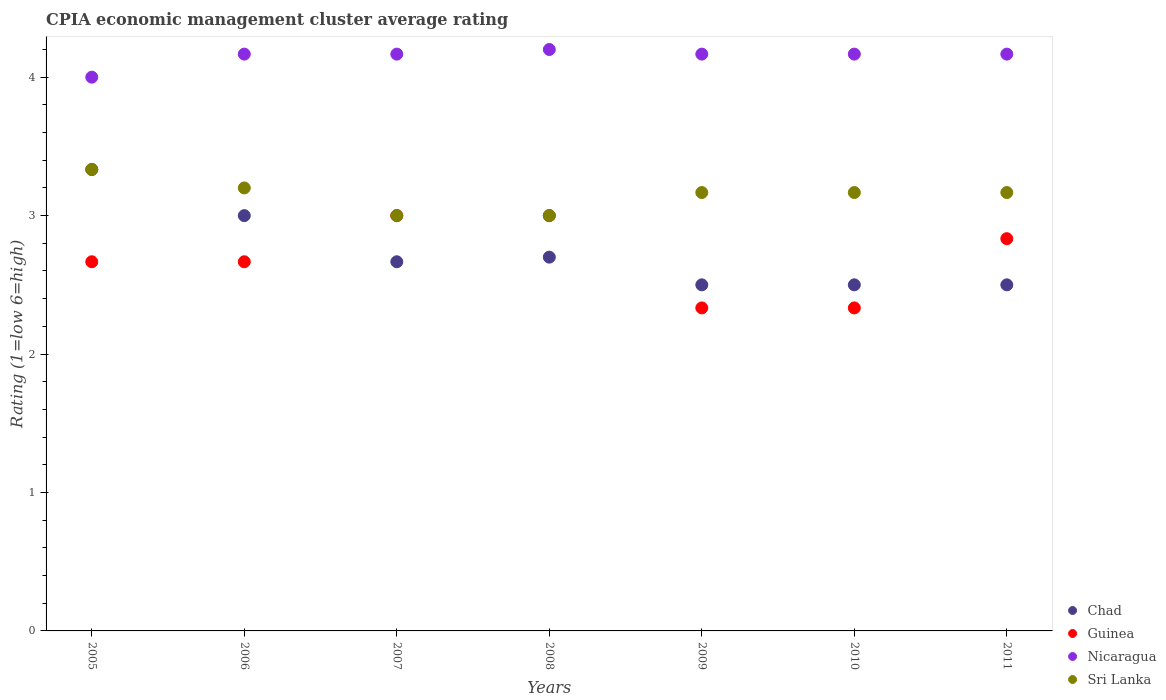How many different coloured dotlines are there?
Make the answer very short. 4. What is the CPIA rating in Chad in 2007?
Your answer should be compact. 2.67. What is the total CPIA rating in Nicaragua in the graph?
Offer a very short reply. 29.03. What is the difference between the CPIA rating in Sri Lanka in 2006 and that in 2008?
Your answer should be compact. 0.2. What is the difference between the CPIA rating in Nicaragua in 2005 and the CPIA rating in Sri Lanka in 2010?
Provide a short and direct response. 0.83. What is the average CPIA rating in Nicaragua per year?
Ensure brevity in your answer.  4.15. In the year 2011, what is the difference between the CPIA rating in Chad and CPIA rating in Sri Lanka?
Provide a succinct answer. -0.67. In how many years, is the CPIA rating in Chad greater than 2?
Offer a terse response. 7. What is the ratio of the CPIA rating in Sri Lanka in 2005 to that in 2011?
Make the answer very short. 1.05. Is the CPIA rating in Nicaragua in 2005 less than that in 2011?
Give a very brief answer. Yes. Is the difference between the CPIA rating in Chad in 2005 and 2008 greater than the difference between the CPIA rating in Sri Lanka in 2005 and 2008?
Offer a terse response. Yes. What is the difference between the highest and the second highest CPIA rating in Guinea?
Make the answer very short. 0. What is the difference between the highest and the lowest CPIA rating in Guinea?
Provide a succinct answer. 0.67. Is it the case that in every year, the sum of the CPIA rating in Chad and CPIA rating in Guinea  is greater than the CPIA rating in Sri Lanka?
Provide a succinct answer. Yes. How many dotlines are there?
Make the answer very short. 4. Are the values on the major ticks of Y-axis written in scientific E-notation?
Your answer should be compact. No. Where does the legend appear in the graph?
Give a very brief answer. Bottom right. How many legend labels are there?
Give a very brief answer. 4. What is the title of the graph?
Provide a short and direct response. CPIA economic management cluster average rating. What is the label or title of the Y-axis?
Your response must be concise. Rating (1=low 6=high). What is the Rating (1=low 6=high) in Chad in 2005?
Your response must be concise. 3.33. What is the Rating (1=low 6=high) in Guinea in 2005?
Ensure brevity in your answer.  2.67. What is the Rating (1=low 6=high) in Sri Lanka in 2005?
Give a very brief answer. 3.33. What is the Rating (1=low 6=high) in Chad in 2006?
Keep it short and to the point. 3. What is the Rating (1=low 6=high) of Guinea in 2006?
Offer a very short reply. 2.67. What is the Rating (1=low 6=high) of Nicaragua in 2006?
Your answer should be very brief. 4.17. What is the Rating (1=low 6=high) in Chad in 2007?
Offer a terse response. 2.67. What is the Rating (1=low 6=high) of Nicaragua in 2007?
Your response must be concise. 4.17. What is the Rating (1=low 6=high) in Guinea in 2008?
Keep it short and to the point. 3. What is the Rating (1=low 6=high) of Nicaragua in 2008?
Your answer should be very brief. 4.2. What is the Rating (1=low 6=high) in Chad in 2009?
Provide a succinct answer. 2.5. What is the Rating (1=low 6=high) in Guinea in 2009?
Your response must be concise. 2.33. What is the Rating (1=low 6=high) of Nicaragua in 2009?
Make the answer very short. 4.17. What is the Rating (1=low 6=high) in Sri Lanka in 2009?
Your answer should be very brief. 3.17. What is the Rating (1=low 6=high) in Chad in 2010?
Provide a short and direct response. 2.5. What is the Rating (1=low 6=high) in Guinea in 2010?
Offer a very short reply. 2.33. What is the Rating (1=low 6=high) of Nicaragua in 2010?
Keep it short and to the point. 4.17. What is the Rating (1=low 6=high) of Sri Lanka in 2010?
Provide a succinct answer. 3.17. What is the Rating (1=low 6=high) of Guinea in 2011?
Your answer should be very brief. 2.83. What is the Rating (1=low 6=high) of Nicaragua in 2011?
Give a very brief answer. 4.17. What is the Rating (1=low 6=high) in Sri Lanka in 2011?
Give a very brief answer. 3.17. Across all years, what is the maximum Rating (1=low 6=high) in Chad?
Give a very brief answer. 3.33. Across all years, what is the maximum Rating (1=low 6=high) in Sri Lanka?
Make the answer very short. 3.33. Across all years, what is the minimum Rating (1=low 6=high) in Chad?
Ensure brevity in your answer.  2.5. Across all years, what is the minimum Rating (1=low 6=high) of Guinea?
Provide a succinct answer. 2.33. Across all years, what is the minimum Rating (1=low 6=high) in Nicaragua?
Keep it short and to the point. 4. Across all years, what is the minimum Rating (1=low 6=high) of Sri Lanka?
Your answer should be very brief. 3. What is the total Rating (1=low 6=high) of Guinea in the graph?
Make the answer very short. 18.83. What is the total Rating (1=low 6=high) in Nicaragua in the graph?
Give a very brief answer. 29.03. What is the total Rating (1=low 6=high) in Sri Lanka in the graph?
Provide a short and direct response. 22.03. What is the difference between the Rating (1=low 6=high) in Chad in 2005 and that in 2006?
Offer a very short reply. 0.33. What is the difference between the Rating (1=low 6=high) of Nicaragua in 2005 and that in 2006?
Offer a terse response. -0.17. What is the difference between the Rating (1=low 6=high) of Sri Lanka in 2005 and that in 2006?
Your answer should be very brief. 0.13. What is the difference between the Rating (1=low 6=high) in Chad in 2005 and that in 2007?
Your response must be concise. 0.67. What is the difference between the Rating (1=low 6=high) in Nicaragua in 2005 and that in 2007?
Give a very brief answer. -0.17. What is the difference between the Rating (1=low 6=high) of Sri Lanka in 2005 and that in 2007?
Offer a very short reply. 0.33. What is the difference between the Rating (1=low 6=high) in Chad in 2005 and that in 2008?
Offer a terse response. 0.63. What is the difference between the Rating (1=low 6=high) in Nicaragua in 2005 and that in 2011?
Keep it short and to the point. -0.17. What is the difference between the Rating (1=low 6=high) of Sri Lanka in 2005 and that in 2011?
Make the answer very short. 0.17. What is the difference between the Rating (1=low 6=high) of Chad in 2006 and that in 2007?
Ensure brevity in your answer.  0.33. What is the difference between the Rating (1=low 6=high) of Guinea in 2006 and that in 2007?
Provide a short and direct response. -0.33. What is the difference between the Rating (1=low 6=high) of Nicaragua in 2006 and that in 2007?
Keep it short and to the point. 0. What is the difference between the Rating (1=low 6=high) in Sri Lanka in 2006 and that in 2007?
Offer a terse response. 0.2. What is the difference between the Rating (1=low 6=high) of Chad in 2006 and that in 2008?
Ensure brevity in your answer.  0.3. What is the difference between the Rating (1=low 6=high) of Nicaragua in 2006 and that in 2008?
Your answer should be compact. -0.03. What is the difference between the Rating (1=low 6=high) in Sri Lanka in 2006 and that in 2009?
Offer a very short reply. 0.03. What is the difference between the Rating (1=low 6=high) in Guinea in 2006 and that in 2010?
Provide a succinct answer. 0.33. What is the difference between the Rating (1=low 6=high) in Nicaragua in 2006 and that in 2010?
Your response must be concise. 0. What is the difference between the Rating (1=low 6=high) of Nicaragua in 2006 and that in 2011?
Your answer should be very brief. 0. What is the difference between the Rating (1=low 6=high) of Sri Lanka in 2006 and that in 2011?
Make the answer very short. 0.03. What is the difference between the Rating (1=low 6=high) of Chad in 2007 and that in 2008?
Your response must be concise. -0.03. What is the difference between the Rating (1=low 6=high) in Guinea in 2007 and that in 2008?
Ensure brevity in your answer.  0. What is the difference between the Rating (1=low 6=high) of Nicaragua in 2007 and that in 2008?
Keep it short and to the point. -0.03. What is the difference between the Rating (1=low 6=high) of Sri Lanka in 2007 and that in 2008?
Give a very brief answer. 0. What is the difference between the Rating (1=low 6=high) in Chad in 2007 and that in 2010?
Provide a short and direct response. 0.17. What is the difference between the Rating (1=low 6=high) in Guinea in 2007 and that in 2010?
Your response must be concise. 0.67. What is the difference between the Rating (1=low 6=high) in Sri Lanka in 2007 and that in 2011?
Provide a succinct answer. -0.17. What is the difference between the Rating (1=low 6=high) in Chad in 2008 and that in 2009?
Your response must be concise. 0.2. What is the difference between the Rating (1=low 6=high) in Guinea in 2008 and that in 2009?
Provide a short and direct response. 0.67. What is the difference between the Rating (1=low 6=high) in Nicaragua in 2008 and that in 2009?
Offer a terse response. 0.03. What is the difference between the Rating (1=low 6=high) in Sri Lanka in 2008 and that in 2009?
Give a very brief answer. -0.17. What is the difference between the Rating (1=low 6=high) in Chad in 2008 and that in 2010?
Offer a very short reply. 0.2. What is the difference between the Rating (1=low 6=high) in Guinea in 2008 and that in 2010?
Keep it short and to the point. 0.67. What is the difference between the Rating (1=low 6=high) in Nicaragua in 2008 and that in 2010?
Your answer should be very brief. 0.03. What is the difference between the Rating (1=low 6=high) of Sri Lanka in 2008 and that in 2010?
Keep it short and to the point. -0.17. What is the difference between the Rating (1=low 6=high) of Chad in 2008 and that in 2011?
Ensure brevity in your answer.  0.2. What is the difference between the Rating (1=low 6=high) in Guinea in 2008 and that in 2011?
Give a very brief answer. 0.17. What is the difference between the Rating (1=low 6=high) in Nicaragua in 2008 and that in 2011?
Your answer should be very brief. 0.03. What is the difference between the Rating (1=low 6=high) of Sri Lanka in 2008 and that in 2011?
Offer a very short reply. -0.17. What is the difference between the Rating (1=low 6=high) of Chad in 2009 and that in 2010?
Provide a succinct answer. 0. What is the difference between the Rating (1=low 6=high) in Guinea in 2009 and that in 2010?
Offer a very short reply. 0. What is the difference between the Rating (1=low 6=high) of Nicaragua in 2009 and that in 2010?
Provide a succinct answer. 0. What is the difference between the Rating (1=low 6=high) of Sri Lanka in 2009 and that in 2010?
Ensure brevity in your answer.  0. What is the difference between the Rating (1=low 6=high) of Chad in 2009 and that in 2011?
Your answer should be very brief. 0. What is the difference between the Rating (1=low 6=high) in Guinea in 2010 and that in 2011?
Keep it short and to the point. -0.5. What is the difference between the Rating (1=low 6=high) of Nicaragua in 2010 and that in 2011?
Keep it short and to the point. 0. What is the difference between the Rating (1=low 6=high) of Sri Lanka in 2010 and that in 2011?
Your response must be concise. 0. What is the difference between the Rating (1=low 6=high) in Chad in 2005 and the Rating (1=low 6=high) in Guinea in 2006?
Offer a terse response. 0.67. What is the difference between the Rating (1=low 6=high) in Chad in 2005 and the Rating (1=low 6=high) in Nicaragua in 2006?
Your response must be concise. -0.83. What is the difference between the Rating (1=low 6=high) of Chad in 2005 and the Rating (1=low 6=high) of Sri Lanka in 2006?
Offer a very short reply. 0.13. What is the difference between the Rating (1=low 6=high) in Guinea in 2005 and the Rating (1=low 6=high) in Nicaragua in 2006?
Make the answer very short. -1.5. What is the difference between the Rating (1=low 6=high) in Guinea in 2005 and the Rating (1=low 6=high) in Sri Lanka in 2006?
Keep it short and to the point. -0.53. What is the difference between the Rating (1=low 6=high) of Nicaragua in 2005 and the Rating (1=low 6=high) of Sri Lanka in 2006?
Your answer should be very brief. 0.8. What is the difference between the Rating (1=low 6=high) of Chad in 2005 and the Rating (1=low 6=high) of Guinea in 2007?
Provide a short and direct response. 0.33. What is the difference between the Rating (1=low 6=high) in Chad in 2005 and the Rating (1=low 6=high) in Sri Lanka in 2007?
Make the answer very short. 0.33. What is the difference between the Rating (1=low 6=high) of Nicaragua in 2005 and the Rating (1=low 6=high) of Sri Lanka in 2007?
Provide a short and direct response. 1. What is the difference between the Rating (1=low 6=high) in Chad in 2005 and the Rating (1=low 6=high) in Guinea in 2008?
Provide a short and direct response. 0.33. What is the difference between the Rating (1=low 6=high) of Chad in 2005 and the Rating (1=low 6=high) of Nicaragua in 2008?
Your answer should be very brief. -0.87. What is the difference between the Rating (1=low 6=high) in Chad in 2005 and the Rating (1=low 6=high) in Sri Lanka in 2008?
Keep it short and to the point. 0.33. What is the difference between the Rating (1=low 6=high) of Guinea in 2005 and the Rating (1=low 6=high) of Nicaragua in 2008?
Make the answer very short. -1.53. What is the difference between the Rating (1=low 6=high) in Guinea in 2005 and the Rating (1=low 6=high) in Sri Lanka in 2008?
Your answer should be compact. -0.33. What is the difference between the Rating (1=low 6=high) in Nicaragua in 2005 and the Rating (1=low 6=high) in Sri Lanka in 2008?
Give a very brief answer. 1. What is the difference between the Rating (1=low 6=high) in Chad in 2005 and the Rating (1=low 6=high) in Sri Lanka in 2009?
Offer a terse response. 0.17. What is the difference between the Rating (1=low 6=high) of Guinea in 2005 and the Rating (1=low 6=high) of Sri Lanka in 2009?
Provide a short and direct response. -0.5. What is the difference between the Rating (1=low 6=high) of Nicaragua in 2005 and the Rating (1=low 6=high) of Sri Lanka in 2009?
Your answer should be compact. 0.83. What is the difference between the Rating (1=low 6=high) of Chad in 2005 and the Rating (1=low 6=high) of Guinea in 2010?
Keep it short and to the point. 1. What is the difference between the Rating (1=low 6=high) in Guinea in 2005 and the Rating (1=low 6=high) in Nicaragua in 2010?
Ensure brevity in your answer.  -1.5. What is the difference between the Rating (1=low 6=high) in Nicaragua in 2005 and the Rating (1=low 6=high) in Sri Lanka in 2010?
Keep it short and to the point. 0.83. What is the difference between the Rating (1=low 6=high) in Chad in 2005 and the Rating (1=low 6=high) in Guinea in 2011?
Provide a short and direct response. 0.5. What is the difference between the Rating (1=low 6=high) in Chad in 2005 and the Rating (1=low 6=high) in Sri Lanka in 2011?
Offer a terse response. 0.17. What is the difference between the Rating (1=low 6=high) of Guinea in 2005 and the Rating (1=low 6=high) of Nicaragua in 2011?
Provide a succinct answer. -1.5. What is the difference between the Rating (1=low 6=high) in Chad in 2006 and the Rating (1=low 6=high) in Guinea in 2007?
Your response must be concise. 0. What is the difference between the Rating (1=low 6=high) in Chad in 2006 and the Rating (1=low 6=high) in Nicaragua in 2007?
Ensure brevity in your answer.  -1.17. What is the difference between the Rating (1=low 6=high) of Guinea in 2006 and the Rating (1=low 6=high) of Nicaragua in 2007?
Provide a short and direct response. -1.5. What is the difference between the Rating (1=low 6=high) in Chad in 2006 and the Rating (1=low 6=high) in Nicaragua in 2008?
Your response must be concise. -1.2. What is the difference between the Rating (1=low 6=high) of Guinea in 2006 and the Rating (1=low 6=high) of Nicaragua in 2008?
Offer a terse response. -1.53. What is the difference between the Rating (1=low 6=high) of Nicaragua in 2006 and the Rating (1=low 6=high) of Sri Lanka in 2008?
Offer a terse response. 1.17. What is the difference between the Rating (1=low 6=high) in Chad in 2006 and the Rating (1=low 6=high) in Nicaragua in 2009?
Your answer should be very brief. -1.17. What is the difference between the Rating (1=low 6=high) of Chad in 2006 and the Rating (1=low 6=high) of Sri Lanka in 2009?
Give a very brief answer. -0.17. What is the difference between the Rating (1=low 6=high) of Nicaragua in 2006 and the Rating (1=low 6=high) of Sri Lanka in 2009?
Provide a succinct answer. 1. What is the difference between the Rating (1=low 6=high) in Chad in 2006 and the Rating (1=low 6=high) in Nicaragua in 2010?
Give a very brief answer. -1.17. What is the difference between the Rating (1=low 6=high) in Guinea in 2006 and the Rating (1=low 6=high) in Nicaragua in 2010?
Keep it short and to the point. -1.5. What is the difference between the Rating (1=low 6=high) in Guinea in 2006 and the Rating (1=low 6=high) in Sri Lanka in 2010?
Your answer should be very brief. -0.5. What is the difference between the Rating (1=low 6=high) of Nicaragua in 2006 and the Rating (1=low 6=high) of Sri Lanka in 2010?
Provide a succinct answer. 1. What is the difference between the Rating (1=low 6=high) in Chad in 2006 and the Rating (1=low 6=high) in Guinea in 2011?
Give a very brief answer. 0.17. What is the difference between the Rating (1=low 6=high) in Chad in 2006 and the Rating (1=low 6=high) in Nicaragua in 2011?
Keep it short and to the point. -1.17. What is the difference between the Rating (1=low 6=high) in Guinea in 2006 and the Rating (1=low 6=high) in Nicaragua in 2011?
Offer a very short reply. -1.5. What is the difference between the Rating (1=low 6=high) in Guinea in 2006 and the Rating (1=low 6=high) in Sri Lanka in 2011?
Offer a very short reply. -0.5. What is the difference between the Rating (1=low 6=high) of Nicaragua in 2006 and the Rating (1=low 6=high) of Sri Lanka in 2011?
Give a very brief answer. 1. What is the difference between the Rating (1=low 6=high) in Chad in 2007 and the Rating (1=low 6=high) in Guinea in 2008?
Your answer should be compact. -0.33. What is the difference between the Rating (1=low 6=high) in Chad in 2007 and the Rating (1=low 6=high) in Nicaragua in 2008?
Give a very brief answer. -1.53. What is the difference between the Rating (1=low 6=high) in Chad in 2007 and the Rating (1=low 6=high) in Nicaragua in 2009?
Your answer should be compact. -1.5. What is the difference between the Rating (1=low 6=high) of Guinea in 2007 and the Rating (1=low 6=high) of Nicaragua in 2009?
Keep it short and to the point. -1.17. What is the difference between the Rating (1=low 6=high) in Nicaragua in 2007 and the Rating (1=low 6=high) in Sri Lanka in 2009?
Provide a short and direct response. 1. What is the difference between the Rating (1=low 6=high) of Chad in 2007 and the Rating (1=low 6=high) of Nicaragua in 2010?
Your response must be concise. -1.5. What is the difference between the Rating (1=low 6=high) of Guinea in 2007 and the Rating (1=low 6=high) of Nicaragua in 2010?
Your answer should be very brief. -1.17. What is the difference between the Rating (1=low 6=high) of Nicaragua in 2007 and the Rating (1=low 6=high) of Sri Lanka in 2010?
Your response must be concise. 1. What is the difference between the Rating (1=low 6=high) in Chad in 2007 and the Rating (1=low 6=high) in Guinea in 2011?
Provide a short and direct response. -0.17. What is the difference between the Rating (1=low 6=high) in Chad in 2007 and the Rating (1=low 6=high) in Nicaragua in 2011?
Keep it short and to the point. -1.5. What is the difference between the Rating (1=low 6=high) of Chad in 2007 and the Rating (1=low 6=high) of Sri Lanka in 2011?
Provide a succinct answer. -0.5. What is the difference between the Rating (1=low 6=high) in Guinea in 2007 and the Rating (1=low 6=high) in Nicaragua in 2011?
Your response must be concise. -1.17. What is the difference between the Rating (1=low 6=high) in Guinea in 2007 and the Rating (1=low 6=high) in Sri Lanka in 2011?
Offer a very short reply. -0.17. What is the difference between the Rating (1=low 6=high) of Chad in 2008 and the Rating (1=low 6=high) of Guinea in 2009?
Make the answer very short. 0.37. What is the difference between the Rating (1=low 6=high) in Chad in 2008 and the Rating (1=low 6=high) in Nicaragua in 2009?
Give a very brief answer. -1.47. What is the difference between the Rating (1=low 6=high) in Chad in 2008 and the Rating (1=low 6=high) in Sri Lanka in 2009?
Give a very brief answer. -0.47. What is the difference between the Rating (1=low 6=high) of Guinea in 2008 and the Rating (1=low 6=high) of Nicaragua in 2009?
Your answer should be very brief. -1.17. What is the difference between the Rating (1=low 6=high) of Guinea in 2008 and the Rating (1=low 6=high) of Sri Lanka in 2009?
Make the answer very short. -0.17. What is the difference between the Rating (1=low 6=high) of Nicaragua in 2008 and the Rating (1=low 6=high) of Sri Lanka in 2009?
Your answer should be very brief. 1.03. What is the difference between the Rating (1=low 6=high) in Chad in 2008 and the Rating (1=low 6=high) in Guinea in 2010?
Give a very brief answer. 0.37. What is the difference between the Rating (1=low 6=high) in Chad in 2008 and the Rating (1=low 6=high) in Nicaragua in 2010?
Offer a very short reply. -1.47. What is the difference between the Rating (1=low 6=high) of Chad in 2008 and the Rating (1=low 6=high) of Sri Lanka in 2010?
Offer a terse response. -0.47. What is the difference between the Rating (1=low 6=high) in Guinea in 2008 and the Rating (1=low 6=high) in Nicaragua in 2010?
Keep it short and to the point. -1.17. What is the difference between the Rating (1=low 6=high) in Chad in 2008 and the Rating (1=low 6=high) in Guinea in 2011?
Your answer should be very brief. -0.13. What is the difference between the Rating (1=low 6=high) of Chad in 2008 and the Rating (1=low 6=high) of Nicaragua in 2011?
Make the answer very short. -1.47. What is the difference between the Rating (1=low 6=high) in Chad in 2008 and the Rating (1=low 6=high) in Sri Lanka in 2011?
Ensure brevity in your answer.  -0.47. What is the difference between the Rating (1=low 6=high) in Guinea in 2008 and the Rating (1=low 6=high) in Nicaragua in 2011?
Give a very brief answer. -1.17. What is the difference between the Rating (1=low 6=high) in Chad in 2009 and the Rating (1=low 6=high) in Guinea in 2010?
Make the answer very short. 0.17. What is the difference between the Rating (1=low 6=high) in Chad in 2009 and the Rating (1=low 6=high) in Nicaragua in 2010?
Your answer should be very brief. -1.67. What is the difference between the Rating (1=low 6=high) in Guinea in 2009 and the Rating (1=low 6=high) in Nicaragua in 2010?
Provide a succinct answer. -1.83. What is the difference between the Rating (1=low 6=high) in Guinea in 2009 and the Rating (1=low 6=high) in Sri Lanka in 2010?
Provide a succinct answer. -0.83. What is the difference between the Rating (1=low 6=high) of Chad in 2009 and the Rating (1=low 6=high) of Guinea in 2011?
Your response must be concise. -0.33. What is the difference between the Rating (1=low 6=high) of Chad in 2009 and the Rating (1=low 6=high) of Nicaragua in 2011?
Offer a very short reply. -1.67. What is the difference between the Rating (1=low 6=high) in Guinea in 2009 and the Rating (1=low 6=high) in Nicaragua in 2011?
Offer a very short reply. -1.83. What is the difference between the Rating (1=low 6=high) in Guinea in 2009 and the Rating (1=low 6=high) in Sri Lanka in 2011?
Your answer should be compact. -0.83. What is the difference between the Rating (1=low 6=high) in Nicaragua in 2009 and the Rating (1=low 6=high) in Sri Lanka in 2011?
Your answer should be compact. 1. What is the difference between the Rating (1=low 6=high) in Chad in 2010 and the Rating (1=low 6=high) in Guinea in 2011?
Provide a succinct answer. -0.33. What is the difference between the Rating (1=low 6=high) of Chad in 2010 and the Rating (1=low 6=high) of Nicaragua in 2011?
Make the answer very short. -1.67. What is the difference between the Rating (1=low 6=high) of Chad in 2010 and the Rating (1=low 6=high) of Sri Lanka in 2011?
Your answer should be very brief. -0.67. What is the difference between the Rating (1=low 6=high) in Guinea in 2010 and the Rating (1=low 6=high) in Nicaragua in 2011?
Your answer should be very brief. -1.83. What is the difference between the Rating (1=low 6=high) of Guinea in 2010 and the Rating (1=low 6=high) of Sri Lanka in 2011?
Make the answer very short. -0.83. What is the average Rating (1=low 6=high) of Chad per year?
Offer a very short reply. 2.74. What is the average Rating (1=low 6=high) in Guinea per year?
Your answer should be compact. 2.69. What is the average Rating (1=low 6=high) in Nicaragua per year?
Provide a short and direct response. 4.15. What is the average Rating (1=low 6=high) in Sri Lanka per year?
Keep it short and to the point. 3.15. In the year 2005, what is the difference between the Rating (1=low 6=high) of Chad and Rating (1=low 6=high) of Guinea?
Provide a succinct answer. 0.67. In the year 2005, what is the difference between the Rating (1=low 6=high) in Guinea and Rating (1=low 6=high) in Nicaragua?
Your answer should be compact. -1.33. In the year 2005, what is the difference between the Rating (1=low 6=high) in Guinea and Rating (1=low 6=high) in Sri Lanka?
Offer a terse response. -0.67. In the year 2006, what is the difference between the Rating (1=low 6=high) of Chad and Rating (1=low 6=high) of Nicaragua?
Your response must be concise. -1.17. In the year 2006, what is the difference between the Rating (1=low 6=high) in Guinea and Rating (1=low 6=high) in Nicaragua?
Your response must be concise. -1.5. In the year 2006, what is the difference between the Rating (1=low 6=high) in Guinea and Rating (1=low 6=high) in Sri Lanka?
Offer a very short reply. -0.53. In the year 2006, what is the difference between the Rating (1=low 6=high) in Nicaragua and Rating (1=low 6=high) in Sri Lanka?
Give a very brief answer. 0.97. In the year 2007, what is the difference between the Rating (1=low 6=high) of Chad and Rating (1=low 6=high) of Nicaragua?
Offer a terse response. -1.5. In the year 2007, what is the difference between the Rating (1=low 6=high) in Chad and Rating (1=low 6=high) in Sri Lanka?
Your answer should be compact. -0.33. In the year 2007, what is the difference between the Rating (1=low 6=high) in Guinea and Rating (1=low 6=high) in Nicaragua?
Ensure brevity in your answer.  -1.17. In the year 2007, what is the difference between the Rating (1=low 6=high) of Guinea and Rating (1=low 6=high) of Sri Lanka?
Make the answer very short. 0. In the year 2008, what is the difference between the Rating (1=low 6=high) of Chad and Rating (1=low 6=high) of Nicaragua?
Ensure brevity in your answer.  -1.5. In the year 2008, what is the difference between the Rating (1=low 6=high) of Guinea and Rating (1=low 6=high) of Sri Lanka?
Your answer should be very brief. 0. In the year 2008, what is the difference between the Rating (1=low 6=high) of Nicaragua and Rating (1=low 6=high) of Sri Lanka?
Provide a succinct answer. 1.2. In the year 2009, what is the difference between the Rating (1=low 6=high) in Chad and Rating (1=low 6=high) in Nicaragua?
Provide a succinct answer. -1.67. In the year 2009, what is the difference between the Rating (1=low 6=high) of Chad and Rating (1=low 6=high) of Sri Lanka?
Your response must be concise. -0.67. In the year 2009, what is the difference between the Rating (1=low 6=high) of Guinea and Rating (1=low 6=high) of Nicaragua?
Offer a terse response. -1.83. In the year 2010, what is the difference between the Rating (1=low 6=high) in Chad and Rating (1=low 6=high) in Nicaragua?
Your response must be concise. -1.67. In the year 2010, what is the difference between the Rating (1=low 6=high) in Chad and Rating (1=low 6=high) in Sri Lanka?
Your answer should be very brief. -0.67. In the year 2010, what is the difference between the Rating (1=low 6=high) of Guinea and Rating (1=low 6=high) of Nicaragua?
Your response must be concise. -1.83. In the year 2010, what is the difference between the Rating (1=low 6=high) of Guinea and Rating (1=low 6=high) of Sri Lanka?
Offer a terse response. -0.83. In the year 2011, what is the difference between the Rating (1=low 6=high) in Chad and Rating (1=low 6=high) in Nicaragua?
Your answer should be compact. -1.67. In the year 2011, what is the difference between the Rating (1=low 6=high) in Guinea and Rating (1=low 6=high) in Nicaragua?
Offer a terse response. -1.33. In the year 2011, what is the difference between the Rating (1=low 6=high) of Guinea and Rating (1=low 6=high) of Sri Lanka?
Offer a very short reply. -0.33. In the year 2011, what is the difference between the Rating (1=low 6=high) of Nicaragua and Rating (1=low 6=high) of Sri Lanka?
Give a very brief answer. 1. What is the ratio of the Rating (1=low 6=high) in Chad in 2005 to that in 2006?
Ensure brevity in your answer.  1.11. What is the ratio of the Rating (1=low 6=high) of Guinea in 2005 to that in 2006?
Ensure brevity in your answer.  1. What is the ratio of the Rating (1=low 6=high) in Nicaragua in 2005 to that in 2006?
Ensure brevity in your answer.  0.96. What is the ratio of the Rating (1=low 6=high) in Sri Lanka in 2005 to that in 2006?
Provide a succinct answer. 1.04. What is the ratio of the Rating (1=low 6=high) of Guinea in 2005 to that in 2007?
Keep it short and to the point. 0.89. What is the ratio of the Rating (1=low 6=high) in Chad in 2005 to that in 2008?
Keep it short and to the point. 1.23. What is the ratio of the Rating (1=low 6=high) of Nicaragua in 2005 to that in 2009?
Give a very brief answer. 0.96. What is the ratio of the Rating (1=low 6=high) of Sri Lanka in 2005 to that in 2009?
Keep it short and to the point. 1.05. What is the ratio of the Rating (1=low 6=high) in Guinea in 2005 to that in 2010?
Make the answer very short. 1.14. What is the ratio of the Rating (1=low 6=high) of Sri Lanka in 2005 to that in 2010?
Offer a terse response. 1.05. What is the ratio of the Rating (1=low 6=high) in Guinea in 2005 to that in 2011?
Keep it short and to the point. 0.94. What is the ratio of the Rating (1=low 6=high) in Nicaragua in 2005 to that in 2011?
Make the answer very short. 0.96. What is the ratio of the Rating (1=low 6=high) of Sri Lanka in 2005 to that in 2011?
Provide a succinct answer. 1.05. What is the ratio of the Rating (1=low 6=high) in Guinea in 2006 to that in 2007?
Offer a terse response. 0.89. What is the ratio of the Rating (1=low 6=high) in Sri Lanka in 2006 to that in 2007?
Offer a terse response. 1.07. What is the ratio of the Rating (1=low 6=high) of Chad in 2006 to that in 2008?
Your answer should be compact. 1.11. What is the ratio of the Rating (1=low 6=high) of Guinea in 2006 to that in 2008?
Your response must be concise. 0.89. What is the ratio of the Rating (1=low 6=high) of Nicaragua in 2006 to that in 2008?
Give a very brief answer. 0.99. What is the ratio of the Rating (1=low 6=high) of Sri Lanka in 2006 to that in 2008?
Your response must be concise. 1.07. What is the ratio of the Rating (1=low 6=high) of Chad in 2006 to that in 2009?
Make the answer very short. 1.2. What is the ratio of the Rating (1=low 6=high) in Guinea in 2006 to that in 2009?
Your answer should be compact. 1.14. What is the ratio of the Rating (1=low 6=high) in Sri Lanka in 2006 to that in 2009?
Provide a succinct answer. 1.01. What is the ratio of the Rating (1=low 6=high) of Chad in 2006 to that in 2010?
Ensure brevity in your answer.  1.2. What is the ratio of the Rating (1=low 6=high) in Guinea in 2006 to that in 2010?
Keep it short and to the point. 1.14. What is the ratio of the Rating (1=low 6=high) of Sri Lanka in 2006 to that in 2010?
Your answer should be very brief. 1.01. What is the ratio of the Rating (1=low 6=high) in Chad in 2006 to that in 2011?
Make the answer very short. 1.2. What is the ratio of the Rating (1=low 6=high) in Guinea in 2006 to that in 2011?
Provide a succinct answer. 0.94. What is the ratio of the Rating (1=low 6=high) of Nicaragua in 2006 to that in 2011?
Give a very brief answer. 1. What is the ratio of the Rating (1=low 6=high) of Sri Lanka in 2006 to that in 2011?
Provide a short and direct response. 1.01. What is the ratio of the Rating (1=low 6=high) of Chad in 2007 to that in 2008?
Provide a succinct answer. 0.99. What is the ratio of the Rating (1=low 6=high) of Nicaragua in 2007 to that in 2008?
Offer a very short reply. 0.99. What is the ratio of the Rating (1=low 6=high) in Chad in 2007 to that in 2009?
Keep it short and to the point. 1.07. What is the ratio of the Rating (1=low 6=high) in Nicaragua in 2007 to that in 2009?
Offer a very short reply. 1. What is the ratio of the Rating (1=low 6=high) of Sri Lanka in 2007 to that in 2009?
Provide a succinct answer. 0.95. What is the ratio of the Rating (1=low 6=high) of Chad in 2007 to that in 2010?
Provide a short and direct response. 1.07. What is the ratio of the Rating (1=low 6=high) in Nicaragua in 2007 to that in 2010?
Your answer should be compact. 1. What is the ratio of the Rating (1=low 6=high) of Sri Lanka in 2007 to that in 2010?
Provide a succinct answer. 0.95. What is the ratio of the Rating (1=low 6=high) of Chad in 2007 to that in 2011?
Your response must be concise. 1.07. What is the ratio of the Rating (1=low 6=high) in Guinea in 2007 to that in 2011?
Your response must be concise. 1.06. What is the ratio of the Rating (1=low 6=high) of Guinea in 2008 to that in 2009?
Your answer should be very brief. 1.29. What is the ratio of the Rating (1=low 6=high) in Guinea in 2008 to that in 2010?
Your answer should be very brief. 1.29. What is the ratio of the Rating (1=low 6=high) in Chad in 2008 to that in 2011?
Ensure brevity in your answer.  1.08. What is the ratio of the Rating (1=low 6=high) of Guinea in 2008 to that in 2011?
Ensure brevity in your answer.  1.06. What is the ratio of the Rating (1=low 6=high) of Chad in 2009 to that in 2010?
Give a very brief answer. 1. What is the ratio of the Rating (1=low 6=high) of Guinea in 2009 to that in 2010?
Your answer should be compact. 1. What is the ratio of the Rating (1=low 6=high) of Nicaragua in 2009 to that in 2010?
Keep it short and to the point. 1. What is the ratio of the Rating (1=low 6=high) of Sri Lanka in 2009 to that in 2010?
Keep it short and to the point. 1. What is the ratio of the Rating (1=low 6=high) of Chad in 2009 to that in 2011?
Your answer should be compact. 1. What is the ratio of the Rating (1=low 6=high) in Guinea in 2009 to that in 2011?
Give a very brief answer. 0.82. What is the ratio of the Rating (1=low 6=high) of Nicaragua in 2009 to that in 2011?
Your answer should be very brief. 1. What is the ratio of the Rating (1=low 6=high) in Chad in 2010 to that in 2011?
Your answer should be compact. 1. What is the ratio of the Rating (1=low 6=high) in Guinea in 2010 to that in 2011?
Provide a short and direct response. 0.82. What is the ratio of the Rating (1=low 6=high) of Nicaragua in 2010 to that in 2011?
Offer a terse response. 1. What is the ratio of the Rating (1=low 6=high) in Sri Lanka in 2010 to that in 2011?
Offer a very short reply. 1. What is the difference between the highest and the second highest Rating (1=low 6=high) of Guinea?
Offer a terse response. 0. What is the difference between the highest and the second highest Rating (1=low 6=high) of Sri Lanka?
Offer a very short reply. 0.13. What is the difference between the highest and the lowest Rating (1=low 6=high) in Guinea?
Make the answer very short. 0.67. What is the difference between the highest and the lowest Rating (1=low 6=high) of Nicaragua?
Offer a very short reply. 0.2. What is the difference between the highest and the lowest Rating (1=low 6=high) in Sri Lanka?
Ensure brevity in your answer.  0.33. 